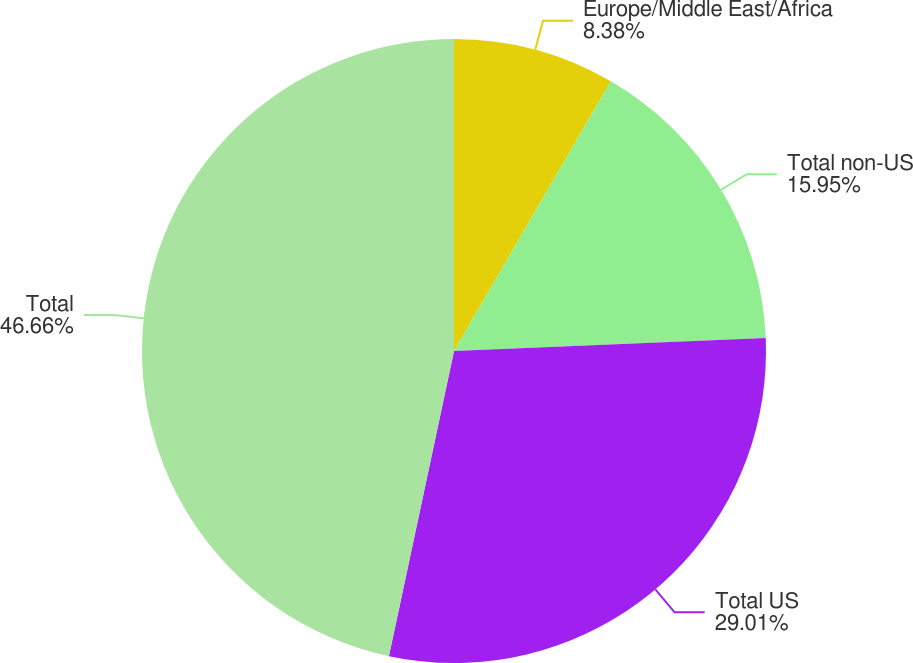Convert chart to OTSL. <chart><loc_0><loc_0><loc_500><loc_500><pie_chart><fcel>Europe/Middle East/Africa<fcel>Total non-US<fcel>Total US<fcel>Total<nl><fcel>8.38%<fcel>15.95%<fcel>29.01%<fcel>46.65%<nl></chart> 